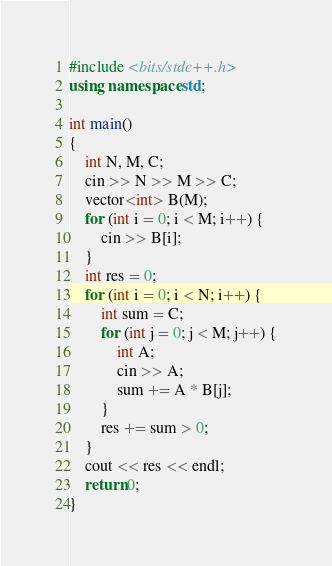Convert code to text. <code><loc_0><loc_0><loc_500><loc_500><_C++_>#include <bits/stdc++.h>
using namespace std;

int main()
{
	int N, M, C;
	cin >> N >> M >> C;
	vector<int> B(M);
	for (int i = 0; i < M; i++) {
		cin >> B[i];
	}
	int res = 0;
	for (int i = 0; i < N; i++) {
		int sum = C;
		for (int j = 0; j < M; j++) {
			int A;
			cin >> A;
			sum += A * B[j];
		}
		res += sum > 0;
	}
	cout << res << endl;
	return 0;
}
</code> 